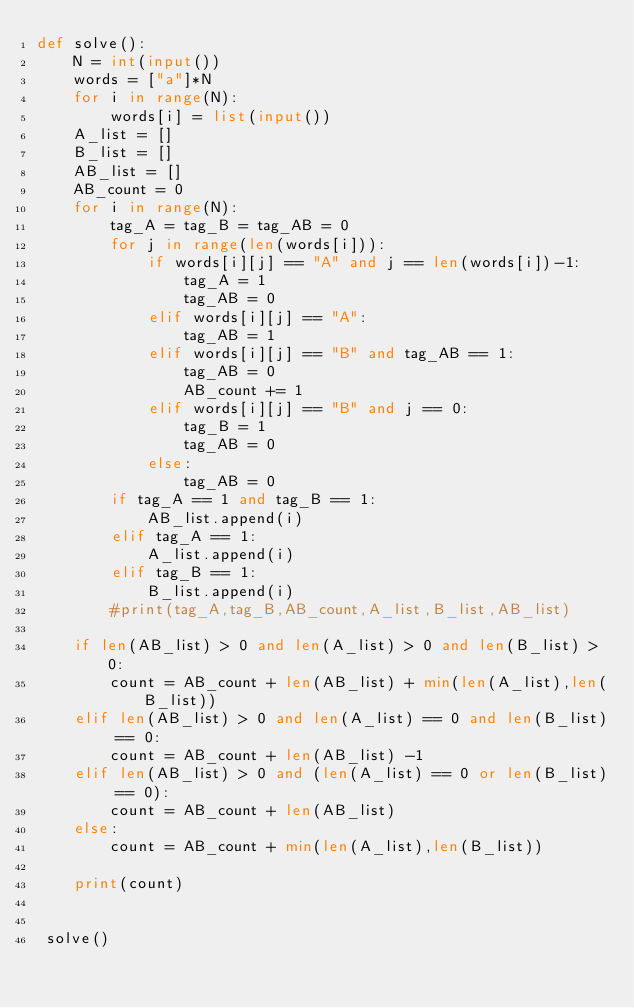Convert code to text. <code><loc_0><loc_0><loc_500><loc_500><_Python_>def solve():
    N = int(input())
    words = ["a"]*N
    for i in range(N):
        words[i] = list(input())
    A_list = []
    B_list = []
    AB_list = [] 
    AB_count = 0
    for i in range(N):
        tag_A = tag_B = tag_AB = 0
        for j in range(len(words[i])):
            if words[i][j] == "A" and j == len(words[i])-1:
                tag_A = 1
                tag_AB = 0
            elif words[i][j] == "A":
                tag_AB = 1
            elif words[i][j] == "B" and tag_AB == 1:
                tag_AB = 0
                AB_count += 1
            elif words[i][j] == "B" and j == 0:
                tag_B = 1
                tag_AB = 0
            else:
                tag_AB = 0
        if tag_A == 1 and tag_B == 1:
            AB_list.append(i)
        elif tag_A == 1:
            A_list.append(i)
        elif tag_B == 1:
            B_list.append(i)
        #print(tag_A,tag_B,AB_count,A_list,B_list,AB_list)

    if len(AB_list) > 0 and len(A_list) > 0 and len(B_list) > 0:
        count = AB_count + len(AB_list) + min(len(A_list),len(B_list))
    elif len(AB_list) > 0 and len(A_list) == 0 and len(B_list) == 0:
        count = AB_count + len(AB_list) -1
    elif len(AB_list) > 0 and (len(A_list) == 0 or len(B_list) == 0):
        count = AB_count + len(AB_list)
    else:
        count = AB_count + min(len(A_list),len(B_list))

    print(count)


 solve()
</code> 